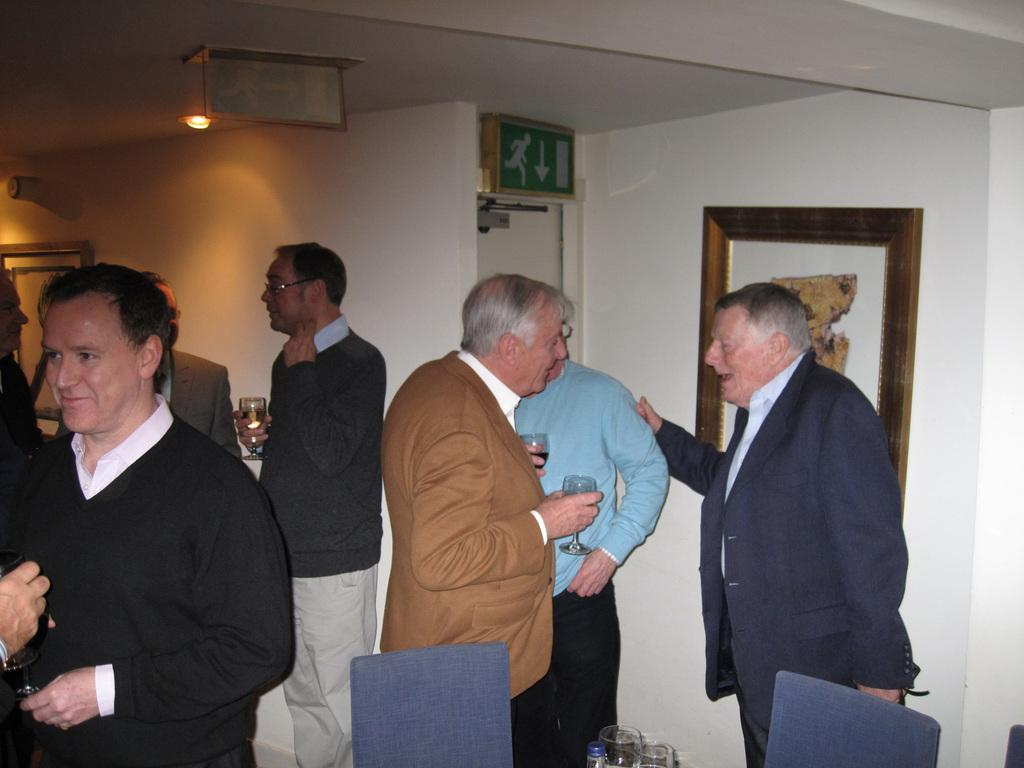What are the men in the image doing? The men in the image are standing and talking. What can be seen in the background of the image? There is a wall in the background of the image. What is on the wall in the image? There is a photo frame and an exit door on the wall. What is the source of light in the image? There is a light on the ceiling in the image. What type of garden can be seen through the exit door in the image? There is no garden visible through the exit door in the image; it leads to an unspecified area. 